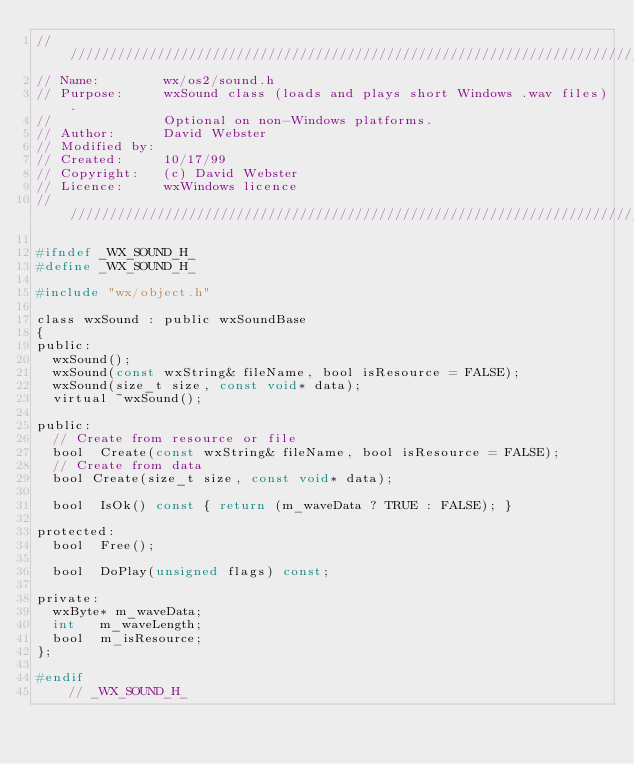Convert code to text. <code><loc_0><loc_0><loc_500><loc_500><_C_>/////////////////////////////////////////////////////////////////////////////
// Name:        wx/os2/sound.h
// Purpose:     wxSound class (loads and plays short Windows .wav files).
//              Optional on non-Windows platforms.
// Author:      David Webster
// Modified by:
// Created:     10/17/99
// Copyright:   (c) David Webster
// Licence:     wxWindows licence
/////////////////////////////////////////////////////////////////////////////

#ifndef _WX_SOUND_H_
#define _WX_SOUND_H_

#include "wx/object.h"

class wxSound : public wxSoundBase
{
public:
  wxSound();
  wxSound(const wxString& fileName, bool isResource = FALSE);
  wxSound(size_t size, const void* data);
  virtual ~wxSound();

public:
  // Create from resource or file
  bool  Create(const wxString& fileName, bool isResource = FALSE);
  // Create from data
  bool Create(size_t size, const void* data);

  bool  IsOk() const { return (m_waveData ? TRUE : FALSE); }

protected:
  bool  Free();

  bool  DoPlay(unsigned flags) const;

private:
  wxByte* m_waveData;
  int   m_waveLength;
  bool  m_isResource;
};

#endif
    // _WX_SOUND_H_
</code> 